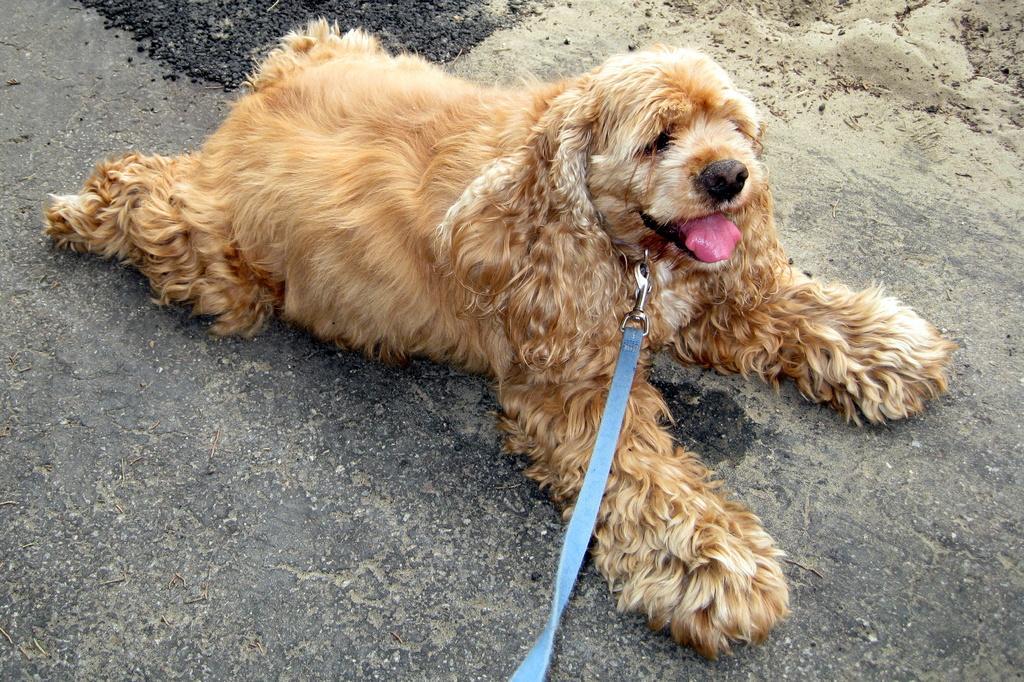Describe this image in one or two sentences. In this image I can see a dog which is brown, cream and black in color is lying on the ground. I can see the blue colored belt. 